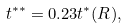<formula> <loc_0><loc_0><loc_500><loc_500>t ^ { * * } = 0 . 2 3 t ^ { * } ( R ) ,</formula> 